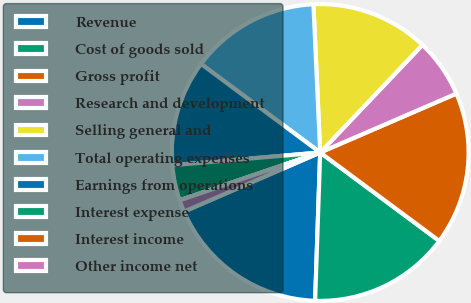Convert chart. <chart><loc_0><loc_0><loc_500><loc_500><pie_chart><fcel>Revenue<fcel>Cost of goods sold<fcel>Gross profit<fcel>Research and development<fcel>Selling general and<fcel>Total operating expenses<fcel>Earnings from operations<fcel>Interest expense<fcel>Interest income<fcel>Other income net<nl><fcel>17.94%<fcel>15.38%<fcel>16.66%<fcel>6.41%<fcel>12.82%<fcel>14.1%<fcel>11.54%<fcel>3.85%<fcel>0.01%<fcel>1.29%<nl></chart> 